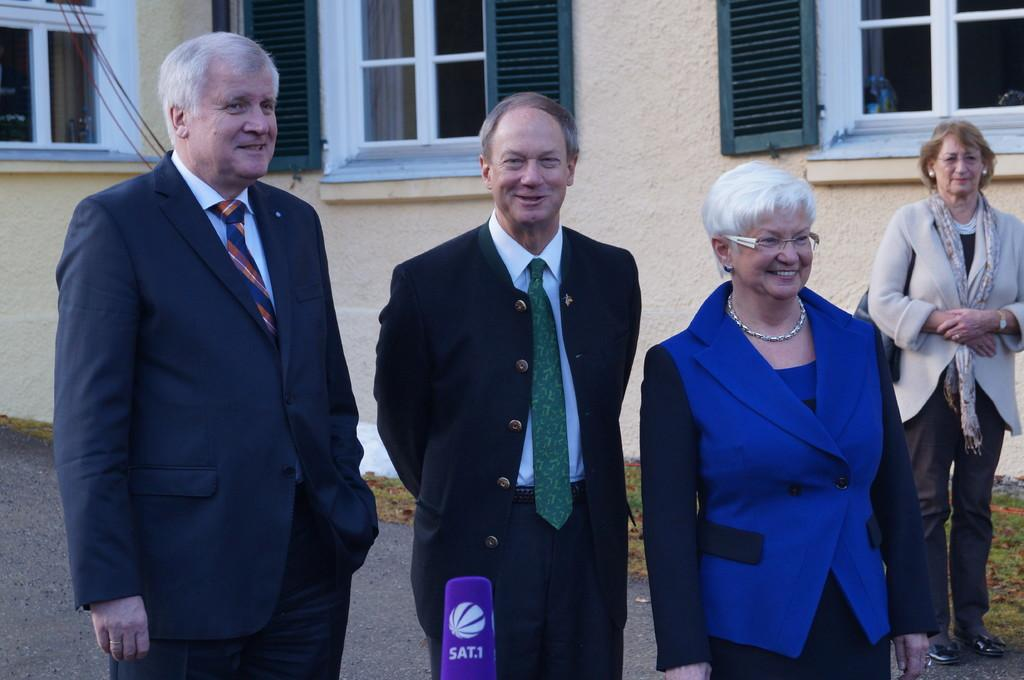Who or what can be seen in the image? There are people in the image. What is the background of the image? There is a wall with windows in the image. What type of surface is visible in the image? The ground is visible in the image. What kind of vegetation is present in the image? There is grass in the image. Can you tell me how many veins are visible on the people in the image? There is no information about veins visible on the people in the image. 